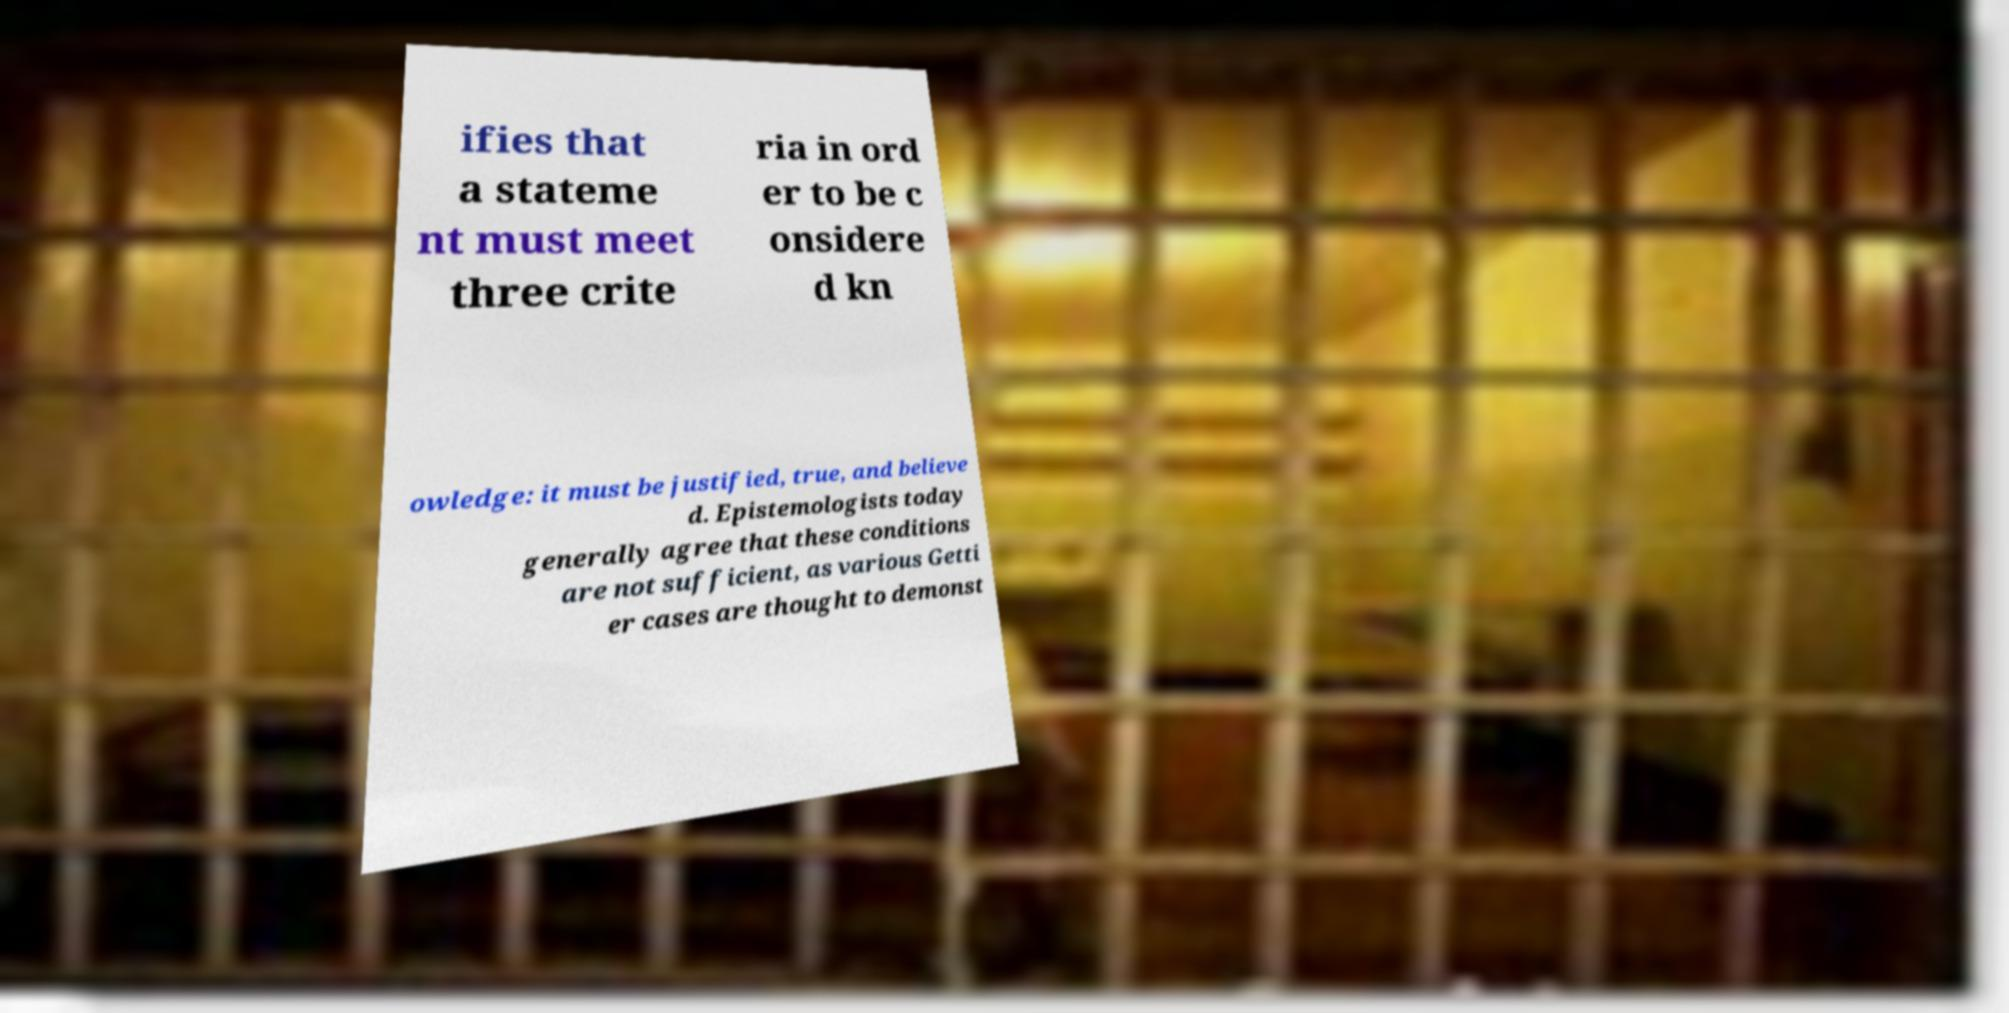Please identify and transcribe the text found in this image. ifies that a stateme nt must meet three crite ria in ord er to be c onsidere d kn owledge: it must be justified, true, and believe d. Epistemologists today generally agree that these conditions are not sufficient, as various Getti er cases are thought to demonst 